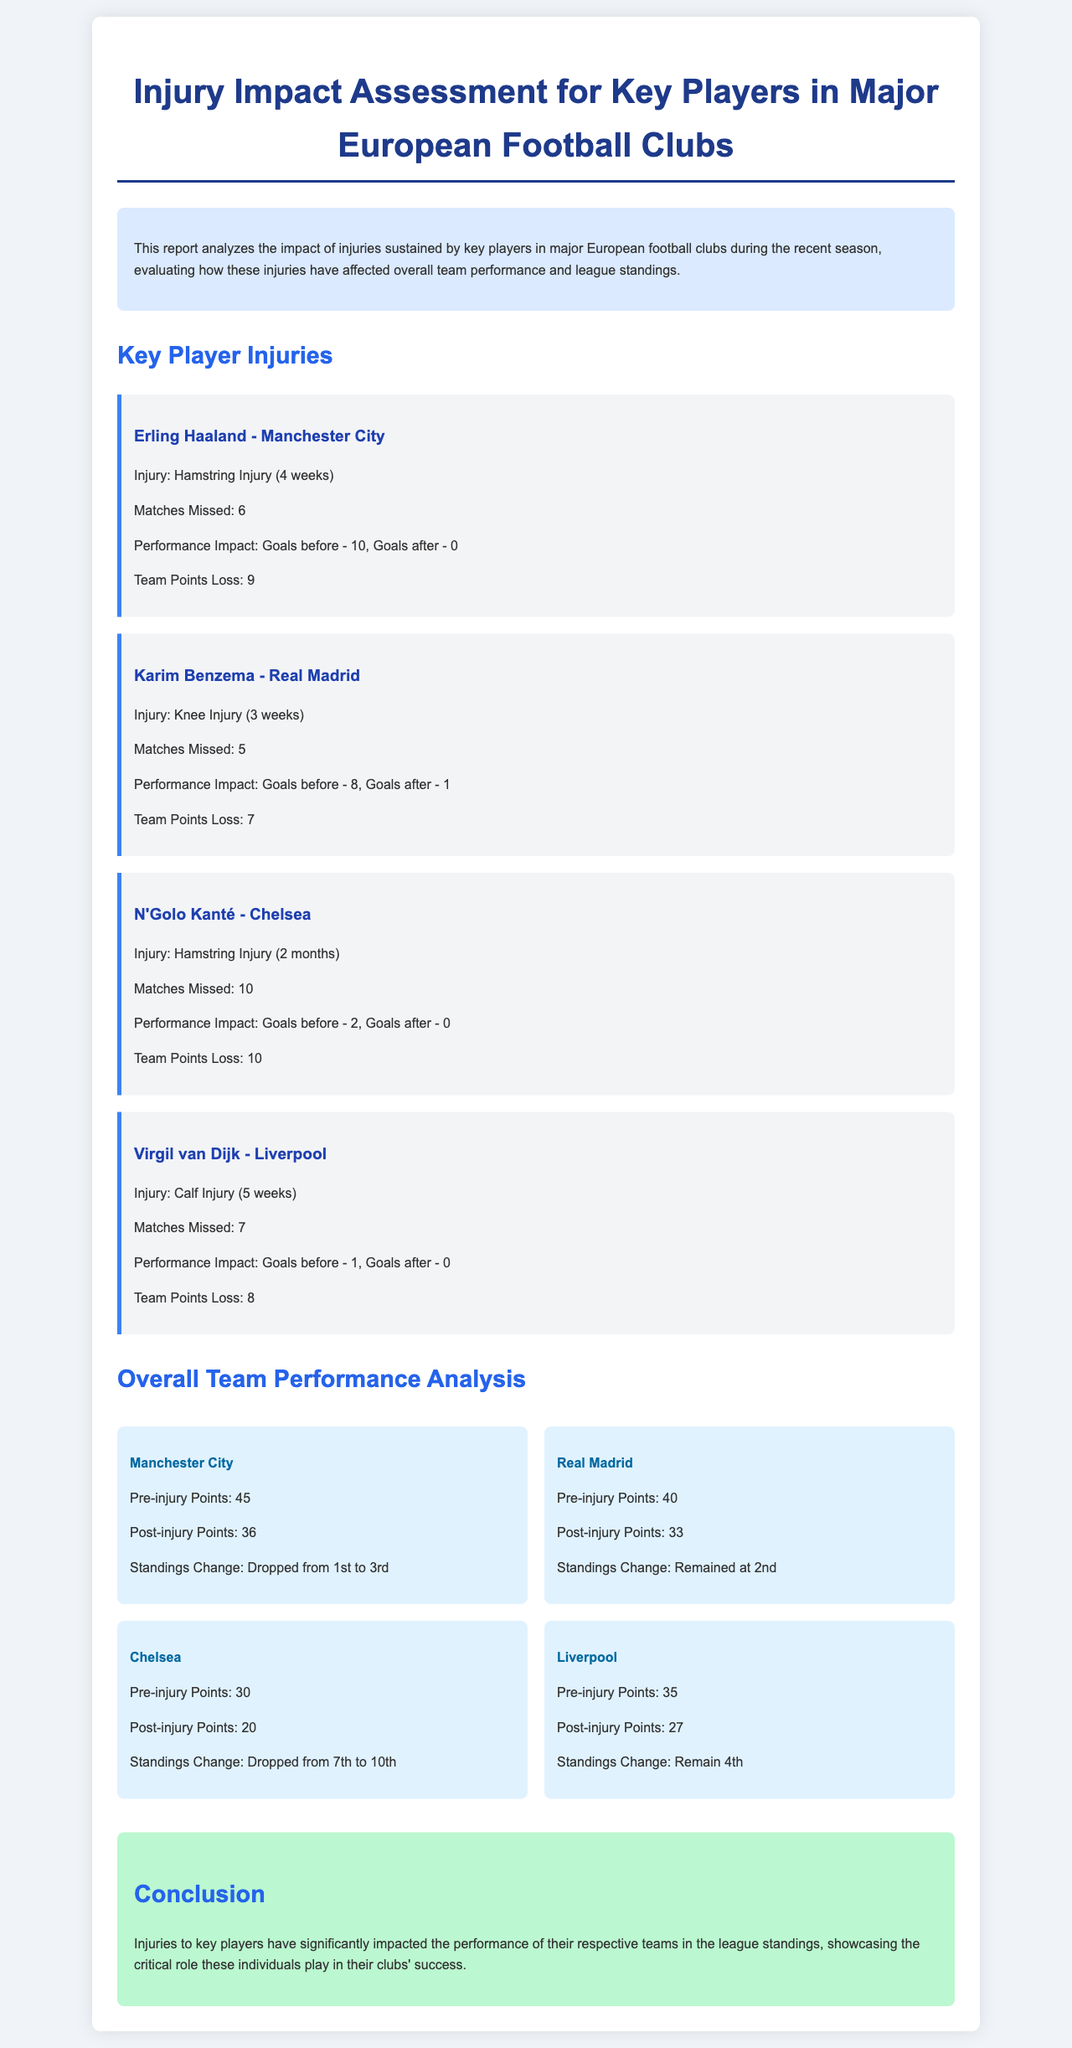What injury did Erling Haaland sustain? The document specifies that Erling Haaland sustained a Hamstring Injury.
Answer: Hamstring Injury How many matches did N'Golo Kanté miss? N'Golo Kanté missed a total of 10 matches due to his injury.
Answer: 10 What was Manchester City's pre-injury points? The document states that Manchester City had 45 points before Haaland's injury.
Answer: 45 What was the performance impact of Karim Benzema's injury? The performance impact after Karim Benzema's injury is detailed as Goals before - 8, Goals after - 1.
Answer: Goals before - 8, Goals after - 1 Which team dropped from 1st to 3rd after the injury? The report highlights that Manchester City dropped from 1st to 3rd place after Haaland's injury.
Answer: Manchester City How many weeks was Virgil van Dijk injured? The document mentions that Virgil van Dijk had a Calf Injury for 5 weeks.
Answer: 5 weeks What was Chelsea's post-injury points? Chelsea's post-injury points are stated as 20 in the document.
Answer: 20 What is the conclusion of the report regarding injuries? The conclusion summarizes that injuries to key players significantly impacted team performance and league standings.
Answer: Injuries to key players have significantly impacted performance How many points did Real Madrid lose after Benzema's injury? Real Madrid lost 7 points after Benzema's injury as indicated in the report.
Answer: 7 